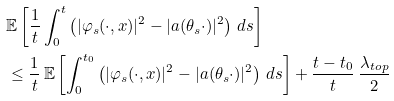Convert formula to latex. <formula><loc_0><loc_0><loc_500><loc_500>& \mathbb { E } \left [ \frac { 1 } { t } \int _ { 0 } ^ { t } \left ( | \varphi _ { s } ( \cdot , x ) | ^ { 2 } - | a ( \theta _ { s } \cdot ) | ^ { 2 } \right ) \, d s \right ] \\ & \leq \frac { 1 } { t } \, \mathbb { E } \left [ \int _ { 0 } ^ { t _ { 0 } } \left ( | \varphi _ { s } ( \cdot , x ) | ^ { 2 } - | a ( \theta _ { s } \cdot ) | ^ { 2 } \right ) \, d s \right ] + \frac { t - t _ { 0 } } { t } \, \frac { \lambda _ { t o p } } { 2 }</formula> 